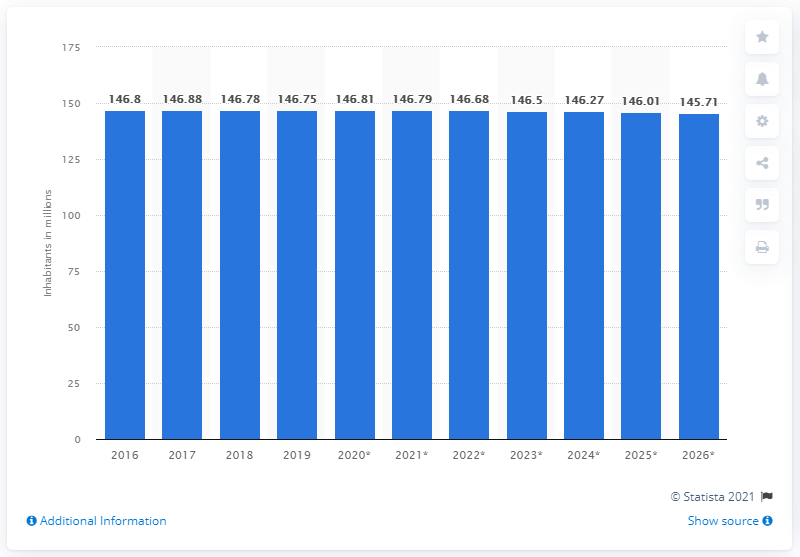Specify some key components in this picture. In 2019, the population of Russia was 145.71 million. 